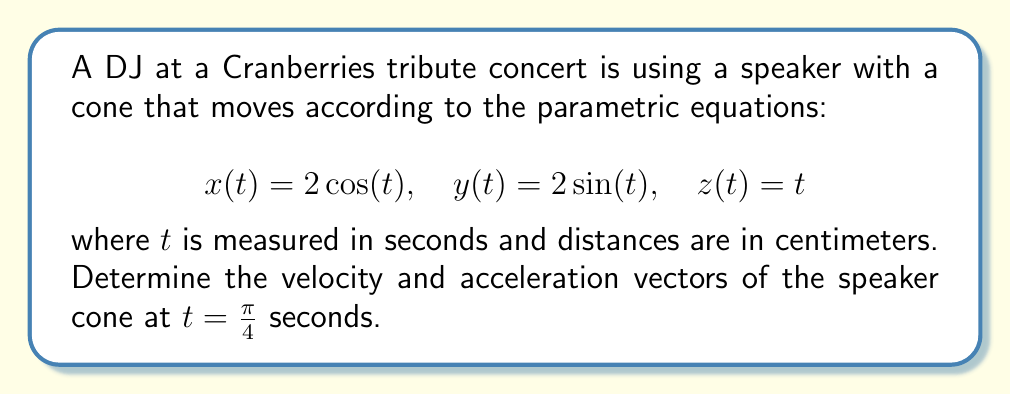Provide a solution to this math problem. To solve this problem, we need to follow these steps:

1) First, let's find the velocity vector. The velocity vector is the first derivative of the position vector with respect to time:

   $$\mathbf{v}(t) = \frac{d\mathbf{r}}{dt} = \left(\frac{dx}{dt}, \frac{dy}{dt}, \frac{dz}{dt}\right)$$

   $$\frac{dx}{dt} = -2\sin(t)$$
   $$\frac{dy}{dt} = 2\cos(t)$$
   $$\frac{dz}{dt} = 1$$

   So, $$\mathbf{v}(t) = (-2\sin(t), 2\cos(t), 1)$$

2) Now, let's find the acceleration vector. The acceleration vector is the second derivative of the position vector, or the first derivative of the velocity vector:

   $$\mathbf{a}(t) = \frac{d\mathbf{v}}{dt} = \left(\frac{d^2x}{dt^2}, \frac{d^2y}{dt^2}, \frac{d^2z}{dt^2}\right)$$

   $$\frac{d^2x}{dt^2} = -2\cos(t)$$
   $$\frac{d^2y}{dt^2} = -2\sin(t)$$
   $$\frac{d^2z}{dt^2} = 0$$

   So, $$\mathbf{a}(t) = (-2\cos(t), -2\sin(t), 0)$$

3) Now we need to evaluate these at $t = \frac{\pi}{4}$:

   For velocity:
   $$\mathbf{v}(\frac{\pi}{4}) = (-2\sin(\frac{\pi}{4}), 2\cos(\frac{\pi}{4}), 1)$$
   
   $$= (-2 \cdot \frac{\sqrt{2}}{2}, 2 \cdot \frac{\sqrt{2}}{2}, 1) = (-\sqrt{2}, \sqrt{2}, 1)$$

   For acceleration:
   $$\mathbf{a}(\frac{\pi}{4}) = (-2\cos(\frac{\pi}{4}), -2\sin(\frac{\pi}{4}), 0)$$
   
   $$= (-2 \cdot \frac{\sqrt{2}}{2}, -2 \cdot \frac{\sqrt{2}}{2}, 0) = (-\sqrt{2}, -\sqrt{2}, 0)$$
Answer: The velocity vector at $t = \frac{\pi}{4}$ is $(-\sqrt{2}, \sqrt{2}, 1)$ cm/s.
The acceleration vector at $t = \frac{\pi}{4}$ is $(-\sqrt{2}, -\sqrt{2}, 0)$ cm/s². 